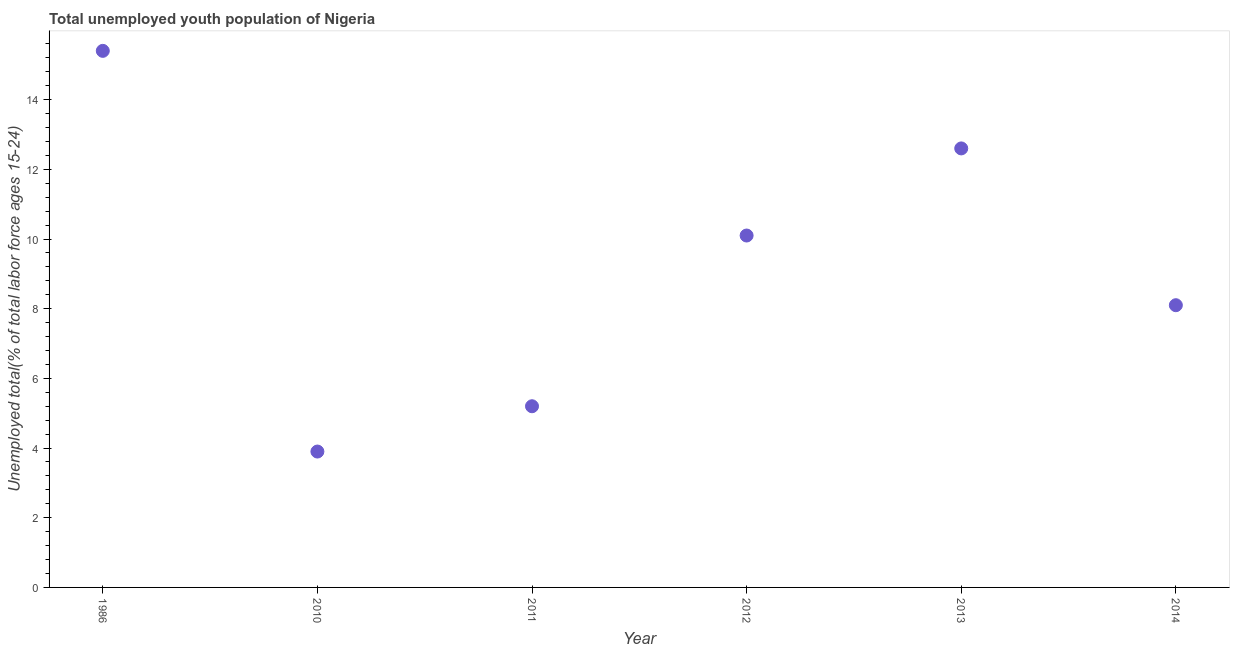What is the unemployed youth in 2011?
Provide a succinct answer. 5.2. Across all years, what is the maximum unemployed youth?
Offer a terse response. 15.4. Across all years, what is the minimum unemployed youth?
Your answer should be very brief. 3.9. What is the sum of the unemployed youth?
Offer a terse response. 55.3. What is the average unemployed youth per year?
Provide a short and direct response. 9.22. What is the median unemployed youth?
Your answer should be very brief. 9.1. Do a majority of the years between 2010 and 2012 (inclusive) have unemployed youth greater than 1.2000000000000002 %?
Ensure brevity in your answer.  Yes. What is the ratio of the unemployed youth in 2012 to that in 2013?
Ensure brevity in your answer.  0.8. What is the difference between the highest and the second highest unemployed youth?
Keep it short and to the point. 2.8. Is the sum of the unemployed youth in 2012 and 2014 greater than the maximum unemployed youth across all years?
Offer a terse response. Yes. What is the difference between the highest and the lowest unemployed youth?
Your answer should be very brief. 11.5. In how many years, is the unemployed youth greater than the average unemployed youth taken over all years?
Your response must be concise. 3. Does the unemployed youth monotonically increase over the years?
Your answer should be compact. No. How many dotlines are there?
Offer a very short reply. 1. Does the graph contain grids?
Offer a terse response. No. What is the title of the graph?
Offer a terse response. Total unemployed youth population of Nigeria. What is the label or title of the Y-axis?
Offer a terse response. Unemployed total(% of total labor force ages 15-24). What is the Unemployed total(% of total labor force ages 15-24) in 1986?
Offer a terse response. 15.4. What is the Unemployed total(% of total labor force ages 15-24) in 2010?
Your answer should be very brief. 3.9. What is the Unemployed total(% of total labor force ages 15-24) in 2011?
Your answer should be very brief. 5.2. What is the Unemployed total(% of total labor force ages 15-24) in 2012?
Your answer should be very brief. 10.1. What is the Unemployed total(% of total labor force ages 15-24) in 2013?
Ensure brevity in your answer.  12.6. What is the Unemployed total(% of total labor force ages 15-24) in 2014?
Your answer should be compact. 8.1. What is the difference between the Unemployed total(% of total labor force ages 15-24) in 1986 and 2010?
Your answer should be compact. 11.5. What is the difference between the Unemployed total(% of total labor force ages 15-24) in 1986 and 2011?
Offer a very short reply. 10.2. What is the difference between the Unemployed total(% of total labor force ages 15-24) in 1986 and 2013?
Offer a terse response. 2.8. What is the difference between the Unemployed total(% of total labor force ages 15-24) in 2010 and 2012?
Your answer should be compact. -6.2. What is the difference between the Unemployed total(% of total labor force ages 15-24) in 2010 and 2014?
Make the answer very short. -4.2. What is the difference between the Unemployed total(% of total labor force ages 15-24) in 2011 and 2012?
Keep it short and to the point. -4.9. What is the difference between the Unemployed total(% of total labor force ages 15-24) in 2011 and 2014?
Provide a succinct answer. -2.9. What is the difference between the Unemployed total(% of total labor force ages 15-24) in 2012 and 2014?
Offer a very short reply. 2. What is the ratio of the Unemployed total(% of total labor force ages 15-24) in 1986 to that in 2010?
Provide a succinct answer. 3.95. What is the ratio of the Unemployed total(% of total labor force ages 15-24) in 1986 to that in 2011?
Make the answer very short. 2.96. What is the ratio of the Unemployed total(% of total labor force ages 15-24) in 1986 to that in 2012?
Your answer should be very brief. 1.52. What is the ratio of the Unemployed total(% of total labor force ages 15-24) in 1986 to that in 2013?
Make the answer very short. 1.22. What is the ratio of the Unemployed total(% of total labor force ages 15-24) in 1986 to that in 2014?
Provide a short and direct response. 1.9. What is the ratio of the Unemployed total(% of total labor force ages 15-24) in 2010 to that in 2011?
Your answer should be compact. 0.75. What is the ratio of the Unemployed total(% of total labor force ages 15-24) in 2010 to that in 2012?
Your answer should be compact. 0.39. What is the ratio of the Unemployed total(% of total labor force ages 15-24) in 2010 to that in 2013?
Provide a succinct answer. 0.31. What is the ratio of the Unemployed total(% of total labor force ages 15-24) in 2010 to that in 2014?
Your response must be concise. 0.48. What is the ratio of the Unemployed total(% of total labor force ages 15-24) in 2011 to that in 2012?
Your response must be concise. 0.52. What is the ratio of the Unemployed total(% of total labor force ages 15-24) in 2011 to that in 2013?
Provide a succinct answer. 0.41. What is the ratio of the Unemployed total(% of total labor force ages 15-24) in 2011 to that in 2014?
Your answer should be very brief. 0.64. What is the ratio of the Unemployed total(% of total labor force ages 15-24) in 2012 to that in 2013?
Offer a very short reply. 0.8. What is the ratio of the Unemployed total(% of total labor force ages 15-24) in 2012 to that in 2014?
Your answer should be very brief. 1.25. What is the ratio of the Unemployed total(% of total labor force ages 15-24) in 2013 to that in 2014?
Provide a succinct answer. 1.56. 